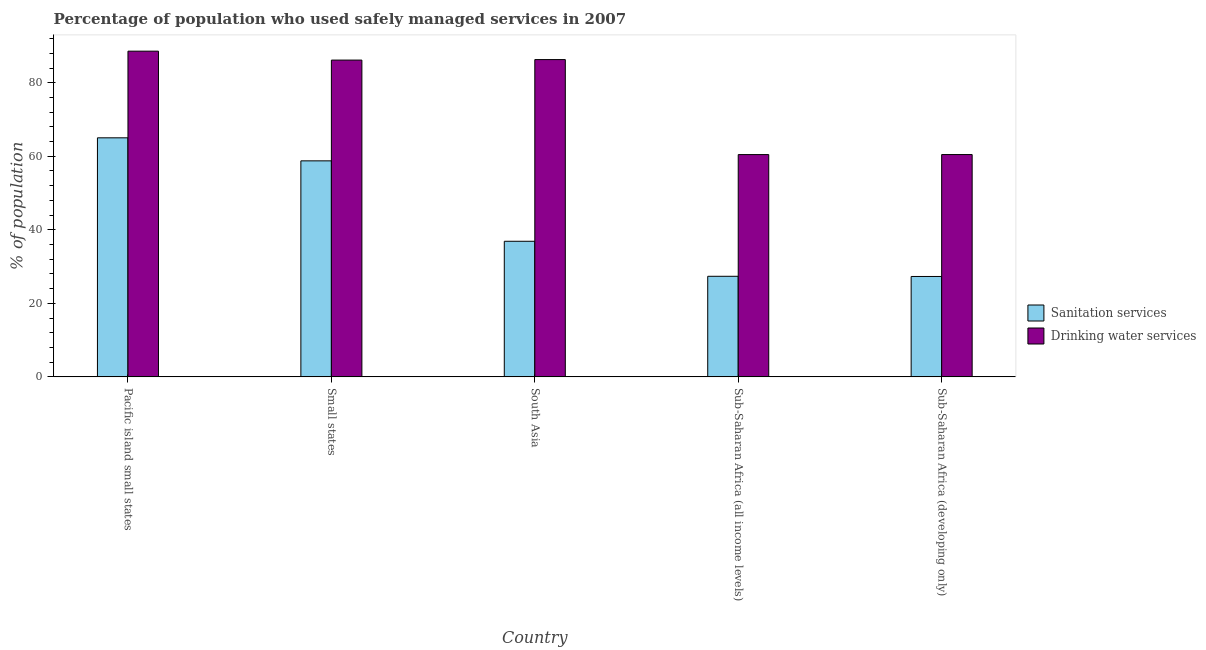Are the number of bars on each tick of the X-axis equal?
Ensure brevity in your answer.  Yes. What is the label of the 5th group of bars from the left?
Offer a very short reply. Sub-Saharan Africa (developing only). What is the percentage of population who used sanitation services in Small states?
Offer a terse response. 58.75. Across all countries, what is the maximum percentage of population who used drinking water services?
Keep it short and to the point. 88.58. Across all countries, what is the minimum percentage of population who used sanitation services?
Make the answer very short. 27.31. In which country was the percentage of population who used drinking water services maximum?
Your answer should be very brief. Pacific island small states. In which country was the percentage of population who used sanitation services minimum?
Provide a succinct answer. Sub-Saharan Africa (developing only). What is the total percentage of population who used sanitation services in the graph?
Your response must be concise. 215.31. What is the difference between the percentage of population who used drinking water services in Pacific island small states and that in Small states?
Your response must be concise. 2.43. What is the difference between the percentage of population who used drinking water services in Small states and the percentage of population who used sanitation services in South Asia?
Ensure brevity in your answer.  49.28. What is the average percentage of population who used drinking water services per country?
Provide a succinct answer. 76.39. What is the difference between the percentage of population who used drinking water services and percentage of population who used sanitation services in Sub-Saharan Africa (all income levels)?
Your answer should be very brief. 33.1. What is the ratio of the percentage of population who used drinking water services in Small states to that in South Asia?
Make the answer very short. 1. Is the percentage of population who used sanitation services in South Asia less than that in Sub-Saharan Africa (all income levels)?
Make the answer very short. No. Is the difference between the percentage of population who used sanitation services in Pacific island small states and Small states greater than the difference between the percentage of population who used drinking water services in Pacific island small states and Small states?
Provide a succinct answer. Yes. What is the difference between the highest and the second highest percentage of population who used drinking water services?
Keep it short and to the point. 2.29. What is the difference between the highest and the lowest percentage of population who used drinking water services?
Your answer should be compact. 28.13. In how many countries, is the percentage of population who used sanitation services greater than the average percentage of population who used sanitation services taken over all countries?
Provide a succinct answer. 2. Is the sum of the percentage of population who used drinking water services in South Asia and Sub-Saharan Africa (developing only) greater than the maximum percentage of population who used sanitation services across all countries?
Your response must be concise. Yes. What does the 1st bar from the left in Sub-Saharan Africa (developing only) represents?
Give a very brief answer. Sanitation services. What does the 1st bar from the right in Pacific island small states represents?
Keep it short and to the point. Drinking water services. How many bars are there?
Give a very brief answer. 10. Are all the bars in the graph horizontal?
Offer a very short reply. No. How many countries are there in the graph?
Your response must be concise. 5. What is the difference between two consecutive major ticks on the Y-axis?
Your answer should be very brief. 20. Are the values on the major ticks of Y-axis written in scientific E-notation?
Ensure brevity in your answer.  No. Does the graph contain any zero values?
Provide a short and direct response. No. Does the graph contain grids?
Your answer should be very brief. No. How many legend labels are there?
Your answer should be compact. 2. How are the legend labels stacked?
Provide a short and direct response. Vertical. What is the title of the graph?
Keep it short and to the point. Percentage of population who used safely managed services in 2007. What is the label or title of the X-axis?
Your answer should be very brief. Country. What is the label or title of the Y-axis?
Ensure brevity in your answer.  % of population. What is the % of population of Sanitation services in Pacific island small states?
Ensure brevity in your answer.  65.02. What is the % of population of Drinking water services in Pacific island small states?
Ensure brevity in your answer.  88.58. What is the % of population in Sanitation services in Small states?
Provide a succinct answer. 58.75. What is the % of population in Drinking water services in Small states?
Offer a very short reply. 86.15. What is the % of population of Sanitation services in South Asia?
Offer a very short reply. 36.88. What is the % of population of Drinking water services in South Asia?
Give a very brief answer. 86.29. What is the % of population in Sanitation services in Sub-Saharan Africa (all income levels)?
Offer a very short reply. 27.36. What is the % of population in Drinking water services in Sub-Saharan Africa (all income levels)?
Ensure brevity in your answer.  60.46. What is the % of population of Sanitation services in Sub-Saharan Africa (developing only)?
Provide a short and direct response. 27.31. What is the % of population in Drinking water services in Sub-Saharan Africa (developing only)?
Offer a very short reply. 60.46. Across all countries, what is the maximum % of population in Sanitation services?
Make the answer very short. 65.02. Across all countries, what is the maximum % of population of Drinking water services?
Provide a succinct answer. 88.58. Across all countries, what is the minimum % of population in Sanitation services?
Your response must be concise. 27.31. Across all countries, what is the minimum % of population of Drinking water services?
Your answer should be compact. 60.46. What is the total % of population in Sanitation services in the graph?
Ensure brevity in your answer.  215.31. What is the total % of population in Drinking water services in the graph?
Give a very brief answer. 381.95. What is the difference between the % of population of Sanitation services in Pacific island small states and that in Small states?
Keep it short and to the point. 6.26. What is the difference between the % of population of Drinking water services in Pacific island small states and that in Small states?
Keep it short and to the point. 2.43. What is the difference between the % of population of Sanitation services in Pacific island small states and that in South Asia?
Provide a short and direct response. 28.14. What is the difference between the % of population of Drinking water services in Pacific island small states and that in South Asia?
Provide a short and direct response. 2.29. What is the difference between the % of population of Sanitation services in Pacific island small states and that in Sub-Saharan Africa (all income levels)?
Keep it short and to the point. 37.66. What is the difference between the % of population of Drinking water services in Pacific island small states and that in Sub-Saharan Africa (all income levels)?
Provide a short and direct response. 28.13. What is the difference between the % of population in Sanitation services in Pacific island small states and that in Sub-Saharan Africa (developing only)?
Give a very brief answer. 37.71. What is the difference between the % of population of Drinking water services in Pacific island small states and that in Sub-Saharan Africa (developing only)?
Provide a short and direct response. 28.12. What is the difference between the % of population of Sanitation services in Small states and that in South Asia?
Give a very brief answer. 21.87. What is the difference between the % of population in Drinking water services in Small states and that in South Asia?
Keep it short and to the point. -0.14. What is the difference between the % of population of Sanitation services in Small states and that in Sub-Saharan Africa (all income levels)?
Make the answer very short. 31.4. What is the difference between the % of population of Drinking water services in Small states and that in Sub-Saharan Africa (all income levels)?
Ensure brevity in your answer.  25.7. What is the difference between the % of population of Sanitation services in Small states and that in Sub-Saharan Africa (developing only)?
Provide a short and direct response. 31.45. What is the difference between the % of population of Drinking water services in Small states and that in Sub-Saharan Africa (developing only)?
Give a very brief answer. 25.69. What is the difference between the % of population in Sanitation services in South Asia and that in Sub-Saharan Africa (all income levels)?
Offer a terse response. 9.52. What is the difference between the % of population in Drinking water services in South Asia and that in Sub-Saharan Africa (all income levels)?
Your response must be concise. 25.83. What is the difference between the % of population of Sanitation services in South Asia and that in Sub-Saharan Africa (developing only)?
Your response must be concise. 9.57. What is the difference between the % of population in Drinking water services in South Asia and that in Sub-Saharan Africa (developing only)?
Provide a succinct answer. 25.83. What is the difference between the % of population of Sanitation services in Sub-Saharan Africa (all income levels) and that in Sub-Saharan Africa (developing only)?
Ensure brevity in your answer.  0.05. What is the difference between the % of population in Drinking water services in Sub-Saharan Africa (all income levels) and that in Sub-Saharan Africa (developing only)?
Provide a succinct answer. -0.01. What is the difference between the % of population in Sanitation services in Pacific island small states and the % of population in Drinking water services in Small states?
Provide a short and direct response. -21.14. What is the difference between the % of population in Sanitation services in Pacific island small states and the % of population in Drinking water services in South Asia?
Your answer should be very brief. -21.28. What is the difference between the % of population of Sanitation services in Pacific island small states and the % of population of Drinking water services in Sub-Saharan Africa (all income levels)?
Provide a succinct answer. 4.56. What is the difference between the % of population in Sanitation services in Pacific island small states and the % of population in Drinking water services in Sub-Saharan Africa (developing only)?
Offer a very short reply. 4.55. What is the difference between the % of population of Sanitation services in Small states and the % of population of Drinking water services in South Asia?
Your answer should be very brief. -27.54. What is the difference between the % of population of Sanitation services in Small states and the % of population of Drinking water services in Sub-Saharan Africa (all income levels)?
Offer a terse response. -1.7. What is the difference between the % of population in Sanitation services in Small states and the % of population in Drinking water services in Sub-Saharan Africa (developing only)?
Keep it short and to the point. -1.71. What is the difference between the % of population in Sanitation services in South Asia and the % of population in Drinking water services in Sub-Saharan Africa (all income levels)?
Your answer should be very brief. -23.58. What is the difference between the % of population in Sanitation services in South Asia and the % of population in Drinking water services in Sub-Saharan Africa (developing only)?
Make the answer very short. -23.59. What is the difference between the % of population in Sanitation services in Sub-Saharan Africa (all income levels) and the % of population in Drinking water services in Sub-Saharan Africa (developing only)?
Keep it short and to the point. -33.11. What is the average % of population in Sanitation services per country?
Give a very brief answer. 43.06. What is the average % of population in Drinking water services per country?
Your response must be concise. 76.39. What is the difference between the % of population in Sanitation services and % of population in Drinking water services in Pacific island small states?
Ensure brevity in your answer.  -23.57. What is the difference between the % of population in Sanitation services and % of population in Drinking water services in Small states?
Provide a short and direct response. -27.4. What is the difference between the % of population in Sanitation services and % of population in Drinking water services in South Asia?
Your answer should be very brief. -49.41. What is the difference between the % of population of Sanitation services and % of population of Drinking water services in Sub-Saharan Africa (all income levels)?
Ensure brevity in your answer.  -33.1. What is the difference between the % of population in Sanitation services and % of population in Drinking water services in Sub-Saharan Africa (developing only)?
Provide a short and direct response. -33.16. What is the ratio of the % of population of Sanitation services in Pacific island small states to that in Small states?
Give a very brief answer. 1.11. What is the ratio of the % of population in Drinking water services in Pacific island small states to that in Small states?
Provide a short and direct response. 1.03. What is the ratio of the % of population of Sanitation services in Pacific island small states to that in South Asia?
Keep it short and to the point. 1.76. What is the ratio of the % of population in Drinking water services in Pacific island small states to that in South Asia?
Give a very brief answer. 1.03. What is the ratio of the % of population of Sanitation services in Pacific island small states to that in Sub-Saharan Africa (all income levels)?
Make the answer very short. 2.38. What is the ratio of the % of population in Drinking water services in Pacific island small states to that in Sub-Saharan Africa (all income levels)?
Your answer should be very brief. 1.47. What is the ratio of the % of population of Sanitation services in Pacific island small states to that in Sub-Saharan Africa (developing only)?
Offer a terse response. 2.38. What is the ratio of the % of population of Drinking water services in Pacific island small states to that in Sub-Saharan Africa (developing only)?
Give a very brief answer. 1.47. What is the ratio of the % of population in Sanitation services in Small states to that in South Asia?
Your answer should be very brief. 1.59. What is the ratio of the % of population in Drinking water services in Small states to that in South Asia?
Provide a short and direct response. 1. What is the ratio of the % of population in Sanitation services in Small states to that in Sub-Saharan Africa (all income levels)?
Keep it short and to the point. 2.15. What is the ratio of the % of population in Drinking water services in Small states to that in Sub-Saharan Africa (all income levels)?
Offer a very short reply. 1.43. What is the ratio of the % of population in Sanitation services in Small states to that in Sub-Saharan Africa (developing only)?
Keep it short and to the point. 2.15. What is the ratio of the % of population of Drinking water services in Small states to that in Sub-Saharan Africa (developing only)?
Ensure brevity in your answer.  1.42. What is the ratio of the % of population in Sanitation services in South Asia to that in Sub-Saharan Africa (all income levels)?
Make the answer very short. 1.35. What is the ratio of the % of population of Drinking water services in South Asia to that in Sub-Saharan Africa (all income levels)?
Provide a short and direct response. 1.43. What is the ratio of the % of population of Sanitation services in South Asia to that in Sub-Saharan Africa (developing only)?
Make the answer very short. 1.35. What is the ratio of the % of population of Drinking water services in South Asia to that in Sub-Saharan Africa (developing only)?
Your answer should be compact. 1.43. What is the ratio of the % of population in Sanitation services in Sub-Saharan Africa (all income levels) to that in Sub-Saharan Africa (developing only)?
Offer a very short reply. 1. What is the ratio of the % of population of Drinking water services in Sub-Saharan Africa (all income levels) to that in Sub-Saharan Africa (developing only)?
Your answer should be very brief. 1. What is the difference between the highest and the second highest % of population of Sanitation services?
Ensure brevity in your answer.  6.26. What is the difference between the highest and the second highest % of population in Drinking water services?
Provide a succinct answer. 2.29. What is the difference between the highest and the lowest % of population in Sanitation services?
Make the answer very short. 37.71. What is the difference between the highest and the lowest % of population of Drinking water services?
Provide a short and direct response. 28.13. 